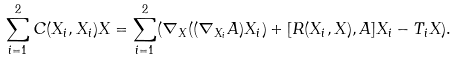<formula> <loc_0><loc_0><loc_500><loc_500>\sum _ { i = 1 } ^ { 2 } C ( X _ { i } , X _ { i } ) X = \sum _ { i = 1 } ^ { 2 } ( \nabla _ { X } ( ( \nabla _ { X _ { i } } A ) X _ { i } ) + [ R ( X _ { i } , X ) , A ] X _ { i } - T _ { i } X ) .</formula> 